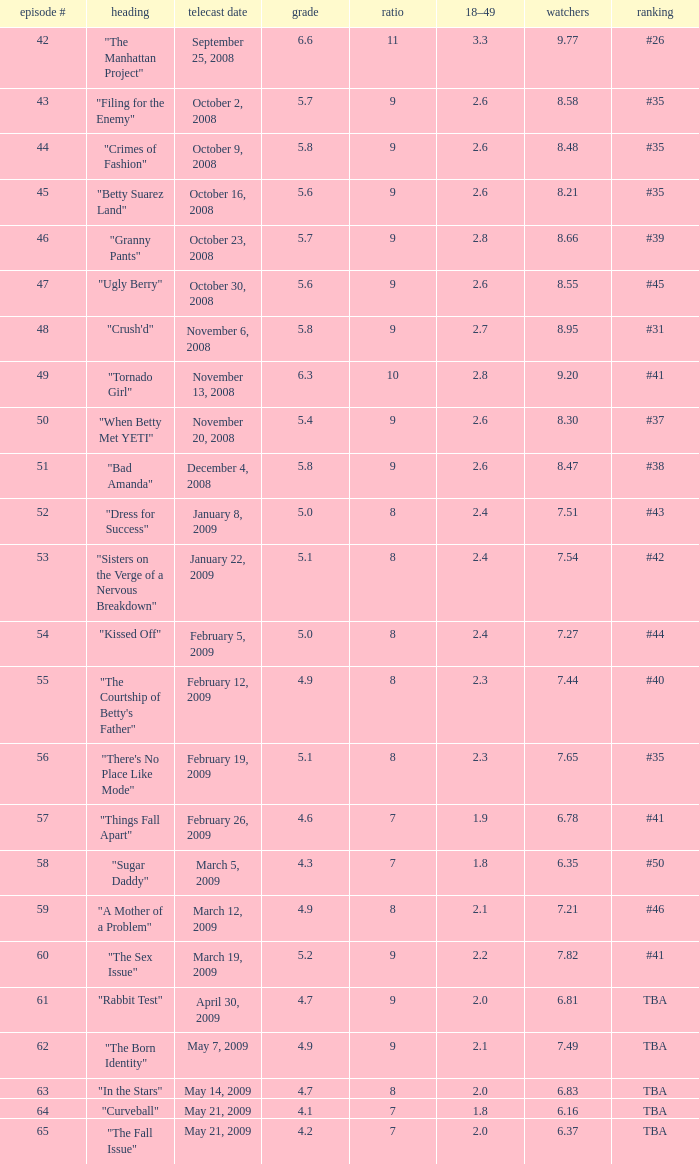What is the lowest Viewers that has an Episode #higher than 58 with a title of "curveball" less than 4.1 rating? None. 